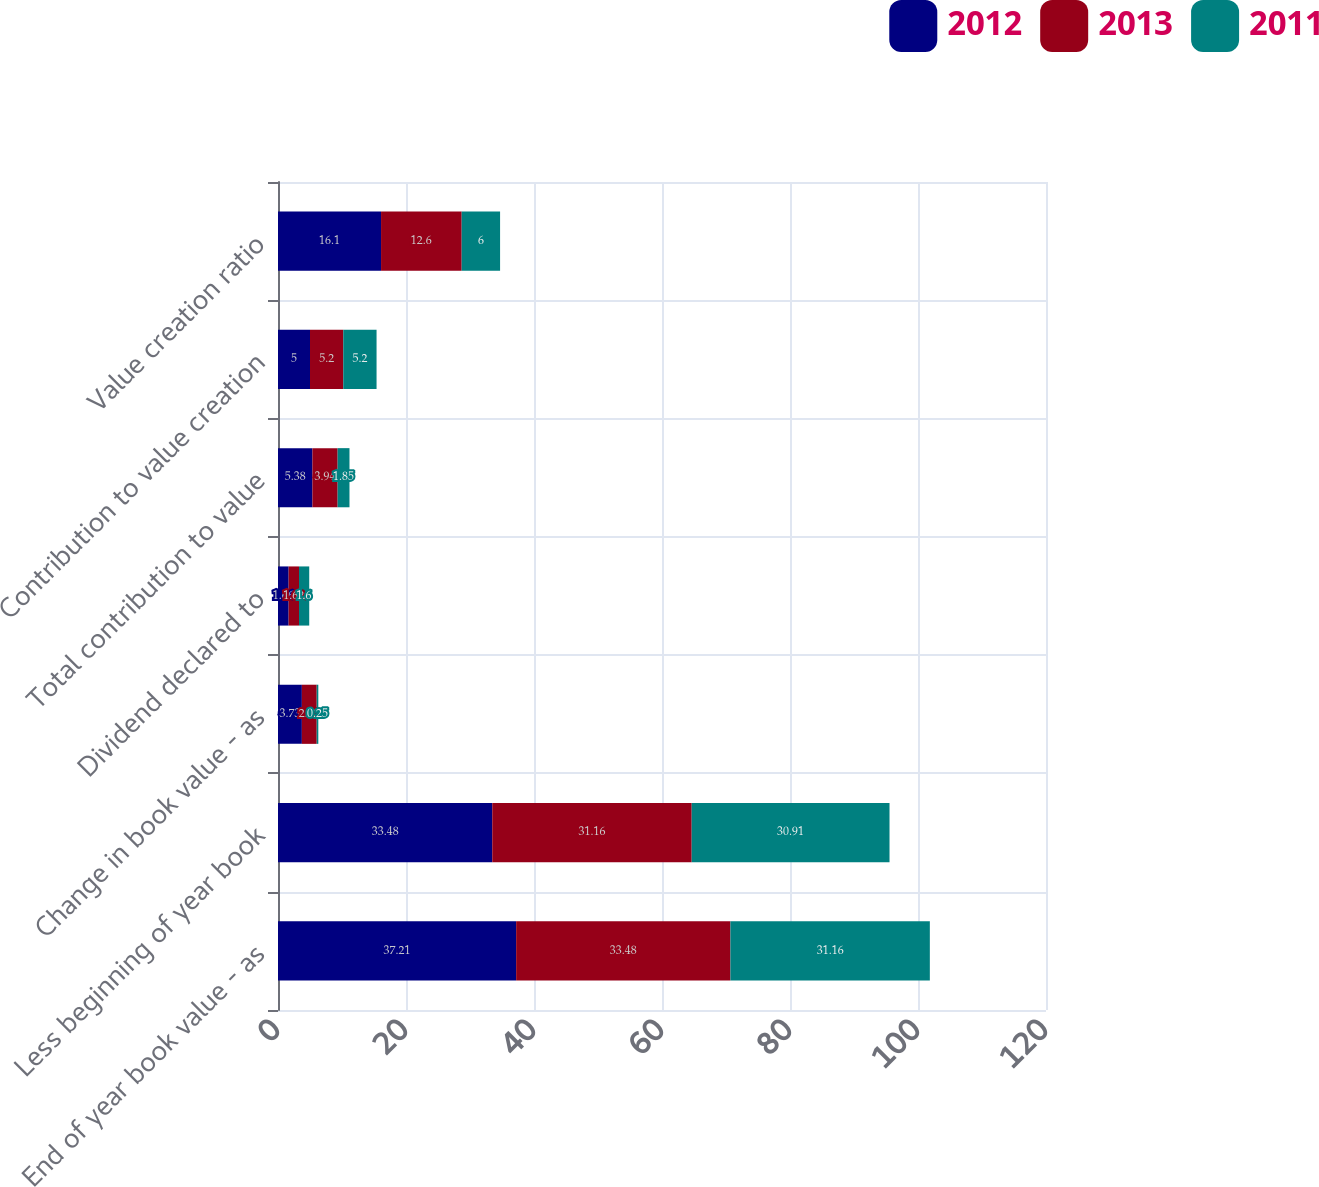<chart> <loc_0><loc_0><loc_500><loc_500><stacked_bar_chart><ecel><fcel>End of year book value - as<fcel>Less beginning of year book<fcel>Change in book value - as<fcel>Dividend declared to<fcel>Total contribution to value<fcel>Contribution to value creation<fcel>Value creation ratio<nl><fcel>2012<fcel>37.21<fcel>33.48<fcel>3.73<fcel>1.66<fcel>5.38<fcel>5<fcel>16.1<nl><fcel>2013<fcel>33.48<fcel>31.16<fcel>2.32<fcel>1.62<fcel>3.94<fcel>5.2<fcel>12.6<nl><fcel>2011<fcel>31.16<fcel>30.91<fcel>0.25<fcel>1.6<fcel>1.85<fcel>5.2<fcel>6<nl></chart> 